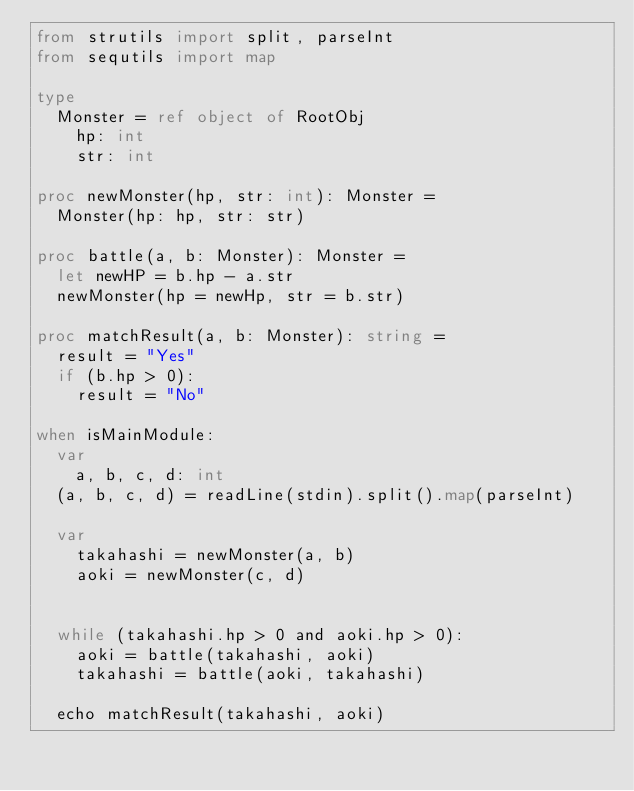<code> <loc_0><loc_0><loc_500><loc_500><_Nim_>from strutils import split, parseInt
from sequtils import map

type
  Monster = ref object of RootObj
    hp: int
    str: int

proc newMonster(hp, str: int): Monster =
  Monster(hp: hp, str: str)

proc battle(a, b: Monster): Monster = 
  let newHP = b.hp - a.str
  newMonster(hp = newHp, str = b.str)

proc matchResult(a, b: Monster): string =
  result = "Yes"
  if (b.hp > 0):
    result = "No"

when isMainModule:
  var
    a, b, c, d: int
  (a, b, c, d) = readLine(stdin).split().map(parseInt)
  
  var
    takahashi = newMonster(a, b)
    aoki = newMonster(c, d)
    
  
  while (takahashi.hp > 0 and aoki.hp > 0):
    aoki = battle(takahashi, aoki)
    takahashi = battle(aoki, takahashi)
  
  echo matchResult(takahashi, aoki)</code> 